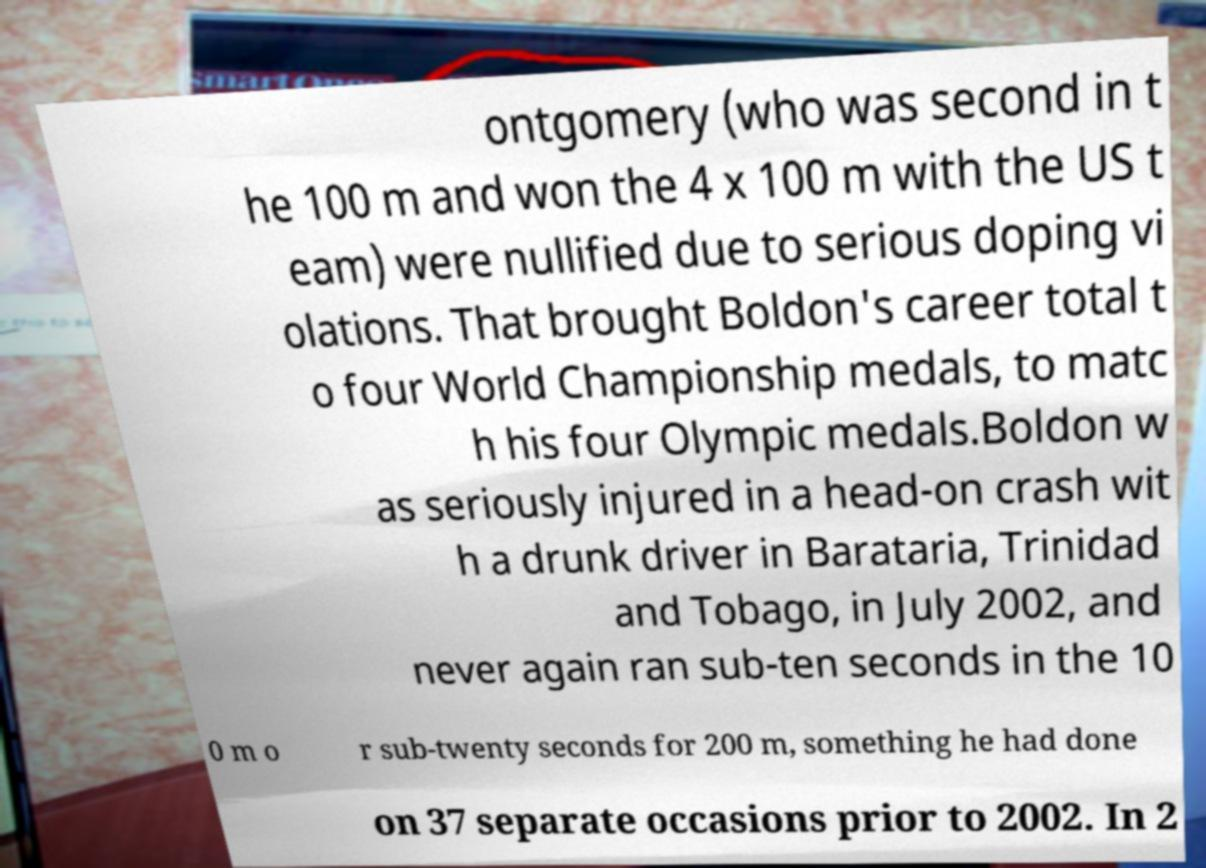Could you assist in decoding the text presented in this image and type it out clearly? ontgomery (who was second in t he 100 m and won the 4 x 100 m with the US t eam) were nullified due to serious doping vi olations. That brought Boldon's career total t o four World Championship medals, to matc h his four Olympic medals.Boldon w as seriously injured in a head-on crash wit h a drunk driver in Barataria, Trinidad and Tobago, in July 2002, and never again ran sub-ten seconds in the 10 0 m o r sub-twenty seconds for 200 m, something he had done on 37 separate occasions prior to 2002. In 2 